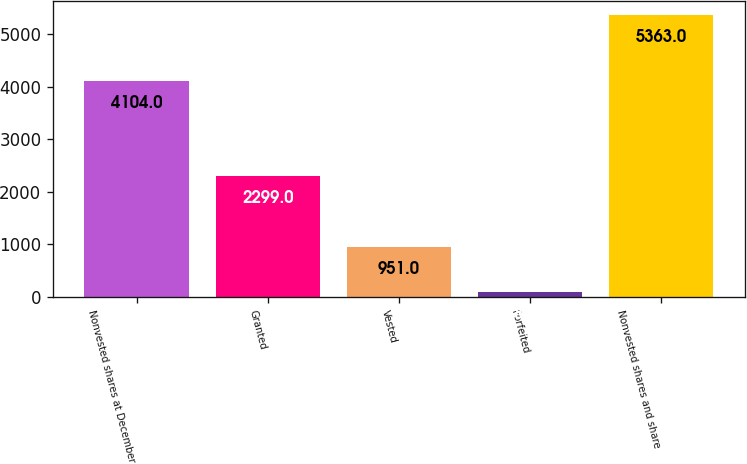Convert chart. <chart><loc_0><loc_0><loc_500><loc_500><bar_chart><fcel>Nonvested shares at December<fcel>Granted<fcel>Vested<fcel>Forfeited<fcel>Nonvested shares and share<nl><fcel>4104<fcel>2299<fcel>951<fcel>89<fcel>5363<nl></chart> 